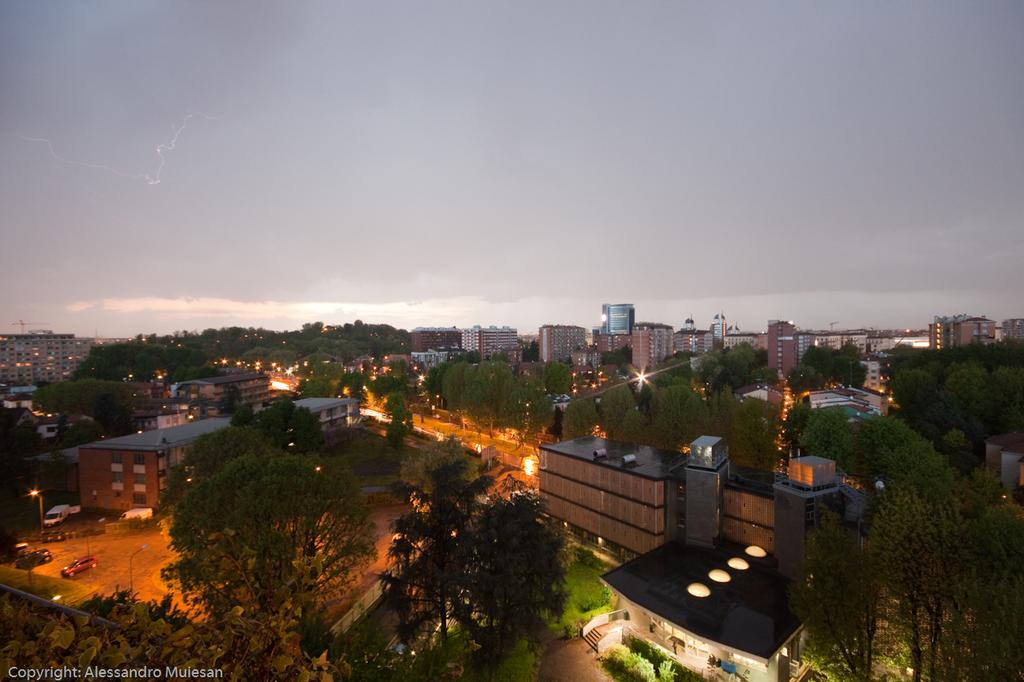What type of objects are on the land in the image? There are vehicles on the land in the image. What can be seen in the background of the image? There are trees and buildings in the background of the image. What type of vegetation is at the bottom of the image? There are plants at the bottom of the image. What structure is located behind the plants? There is a house behind the plants. What is visible at the top of the image? The sky is visible at the top of the image. How many fingers are visible in the image? There are no fingers visible in the image. What type of harmony is being played by the group in the image? There is no group or harmony present in the image. 